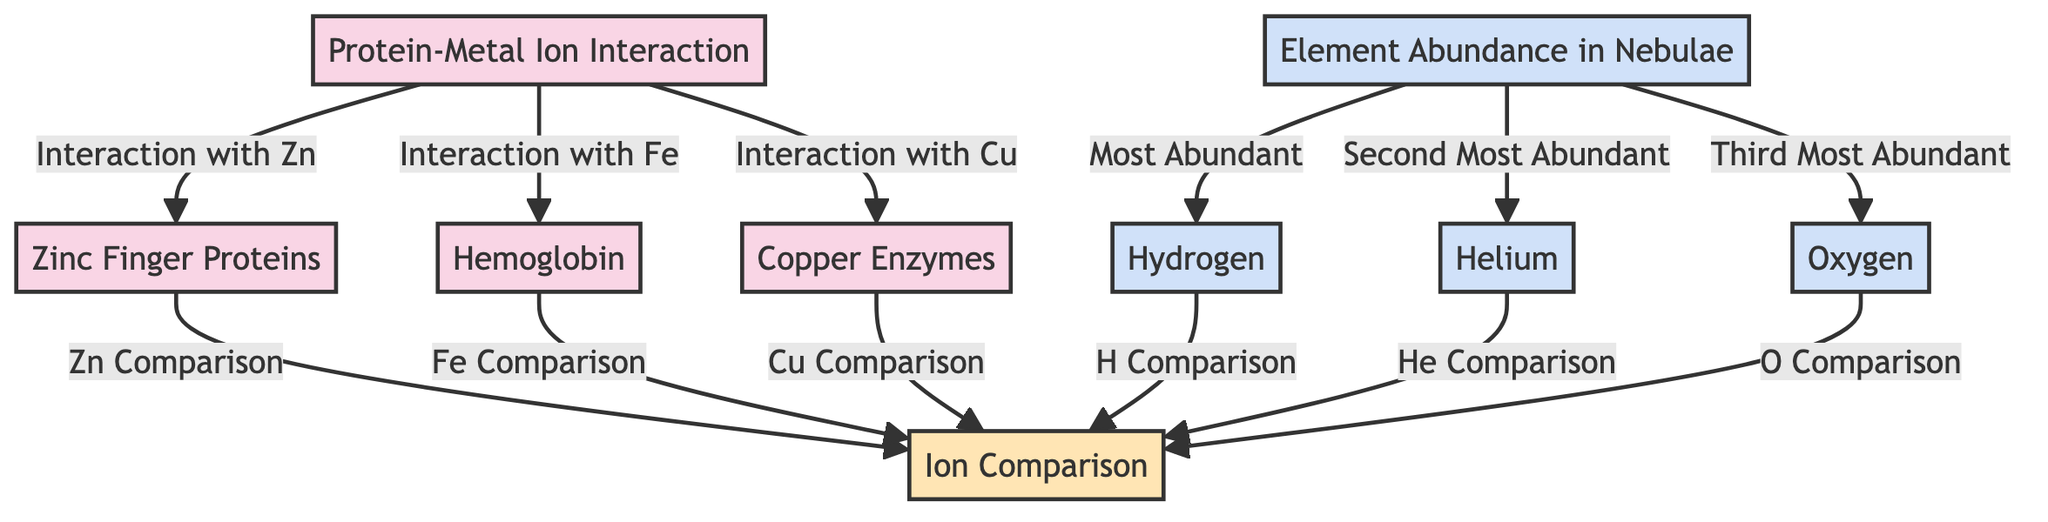What do Zinc Finger Proteins interact with? The diagram specifies that the interaction for Zinc Finger Proteins is with Zinc. This is indicated by the directed edge from Protein-Metal Ion Interaction to Zinc Finger Proteins, labeled "Interaction with Zn".
Answer: Zinc What is the most abundant element in nebulae according to the diagram? In the provided diagram, the most abundant element in nebulae is Hydrogen. This is indicated by a direct link from Element Abundance in Nebulae to Hydrogen labeled "Most Abundant".
Answer: Hydrogen How many protein-metal ion interactions are represented in the diagram? The diagram showcases three interactions (Zinc with Zinc Finger Proteins, Iron with Hemoglobin, and Copper with Copper Enzymes), represented by three directed edges from the Protein-Metal Ion Interaction node.
Answer: Three What is the relationship between Hemoglobin and Element Abundance? Hemoglobin interacts with Iron, and Iron's comparison is linked to the Ion Comparison node, which is a consistent theme across elements in nebulae, showing the importance of the comparison in understanding element abundance. This indicates an indirect relationship through the comparison of metal ions involved.
Answer: Comparison How many elements are compared in the diagram? The diagram allows for comparisons of three elements (Hydrogen, Helium, and Oxygen) stemming from the Element Abundance in Nebulae node to the Ion Comparison node, where it says "H Comparison", "He Comparison", and "O Comparison". Hence, there are three elements compared.
Answer: Three What is the second most abundant element in nebulae? According to the diagram, the second most abundant element in nebulae is Helium, as indicated by the link from Element Abundance in Nebulae to Helium with the label "Second Most Abundant".
Answer: Helium Which protein is linked to Copper ions? The diagram indicates that Copper Enzymes are the proteins linked to Copper ions, as shown by the directed arrow labeled "Interaction with Cu" from the Protein-Metal Ion Interaction node to the Copper Enzymes node.
Answer: Copper Enzymes Which two elements are directly connected to the Ion Comparison node? The two elements directly connected to the Ion Comparison node are Hydrogen and Helium. This is evident as both are linked from their respective abundance nodes to the Ion Comparison node with the labels "H Comparison" and "He Comparison".
Answer: Hydrogen and Helium How many total nodes are there in the diagram? The diagram contains a total of eight nodes: three biochemistry nodes (PMI, ZFP, HGB, CE), one comparison node (IC), and four astronomy nodes (NA, H, He, O). Adding these together gives a total of eight nodes represented.
Answer: Eight 